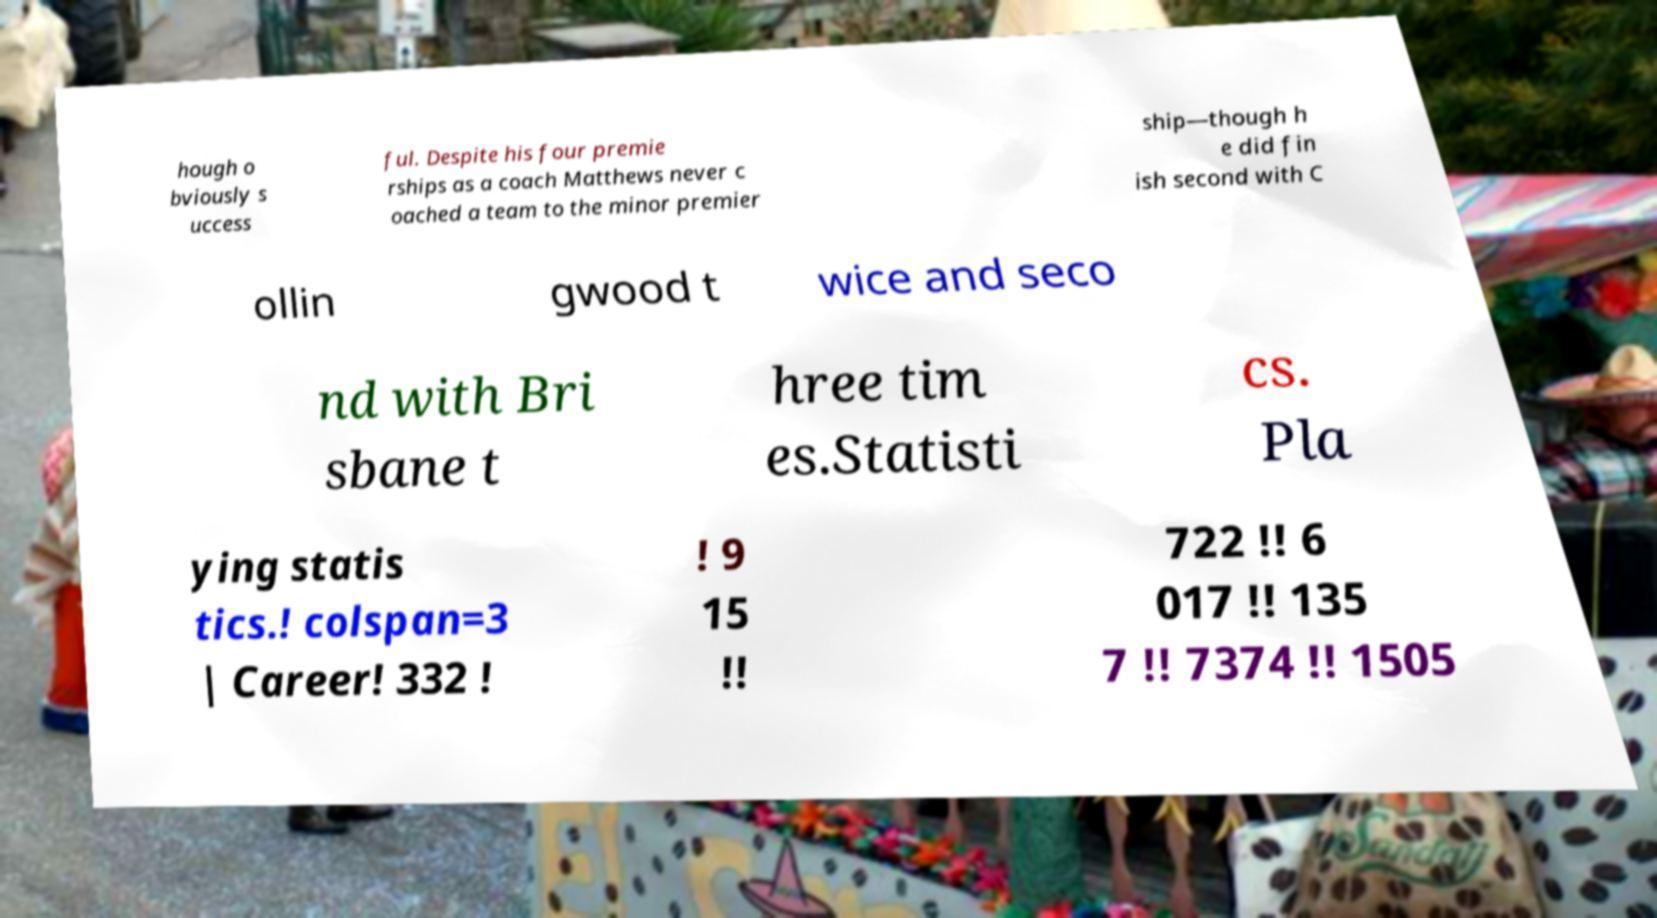Please read and relay the text visible in this image. What does it say? hough o bviously s uccess ful. Despite his four premie rships as a coach Matthews never c oached a team to the minor premier ship—though h e did fin ish second with C ollin gwood t wice and seco nd with Bri sbane t hree tim es.Statisti cs. Pla ying statis tics.! colspan=3 | Career! 332 ! ! 9 15 !! 722 !! 6 017 !! 135 7 !! 7374 !! 1505 